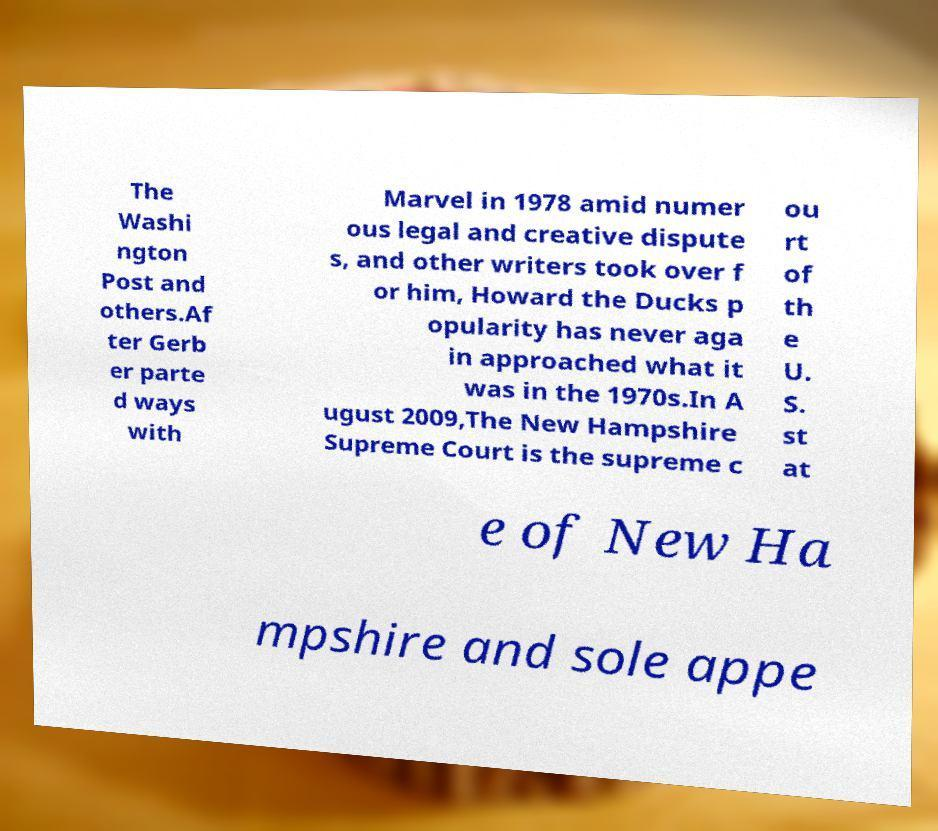Could you assist in decoding the text presented in this image and type it out clearly? The Washi ngton Post and others.Af ter Gerb er parte d ways with Marvel in 1978 amid numer ous legal and creative dispute s, and other writers took over f or him, Howard the Ducks p opularity has never aga in approached what it was in the 1970s.In A ugust 2009,The New Hampshire Supreme Court is the supreme c ou rt of th e U. S. st at e of New Ha mpshire and sole appe 